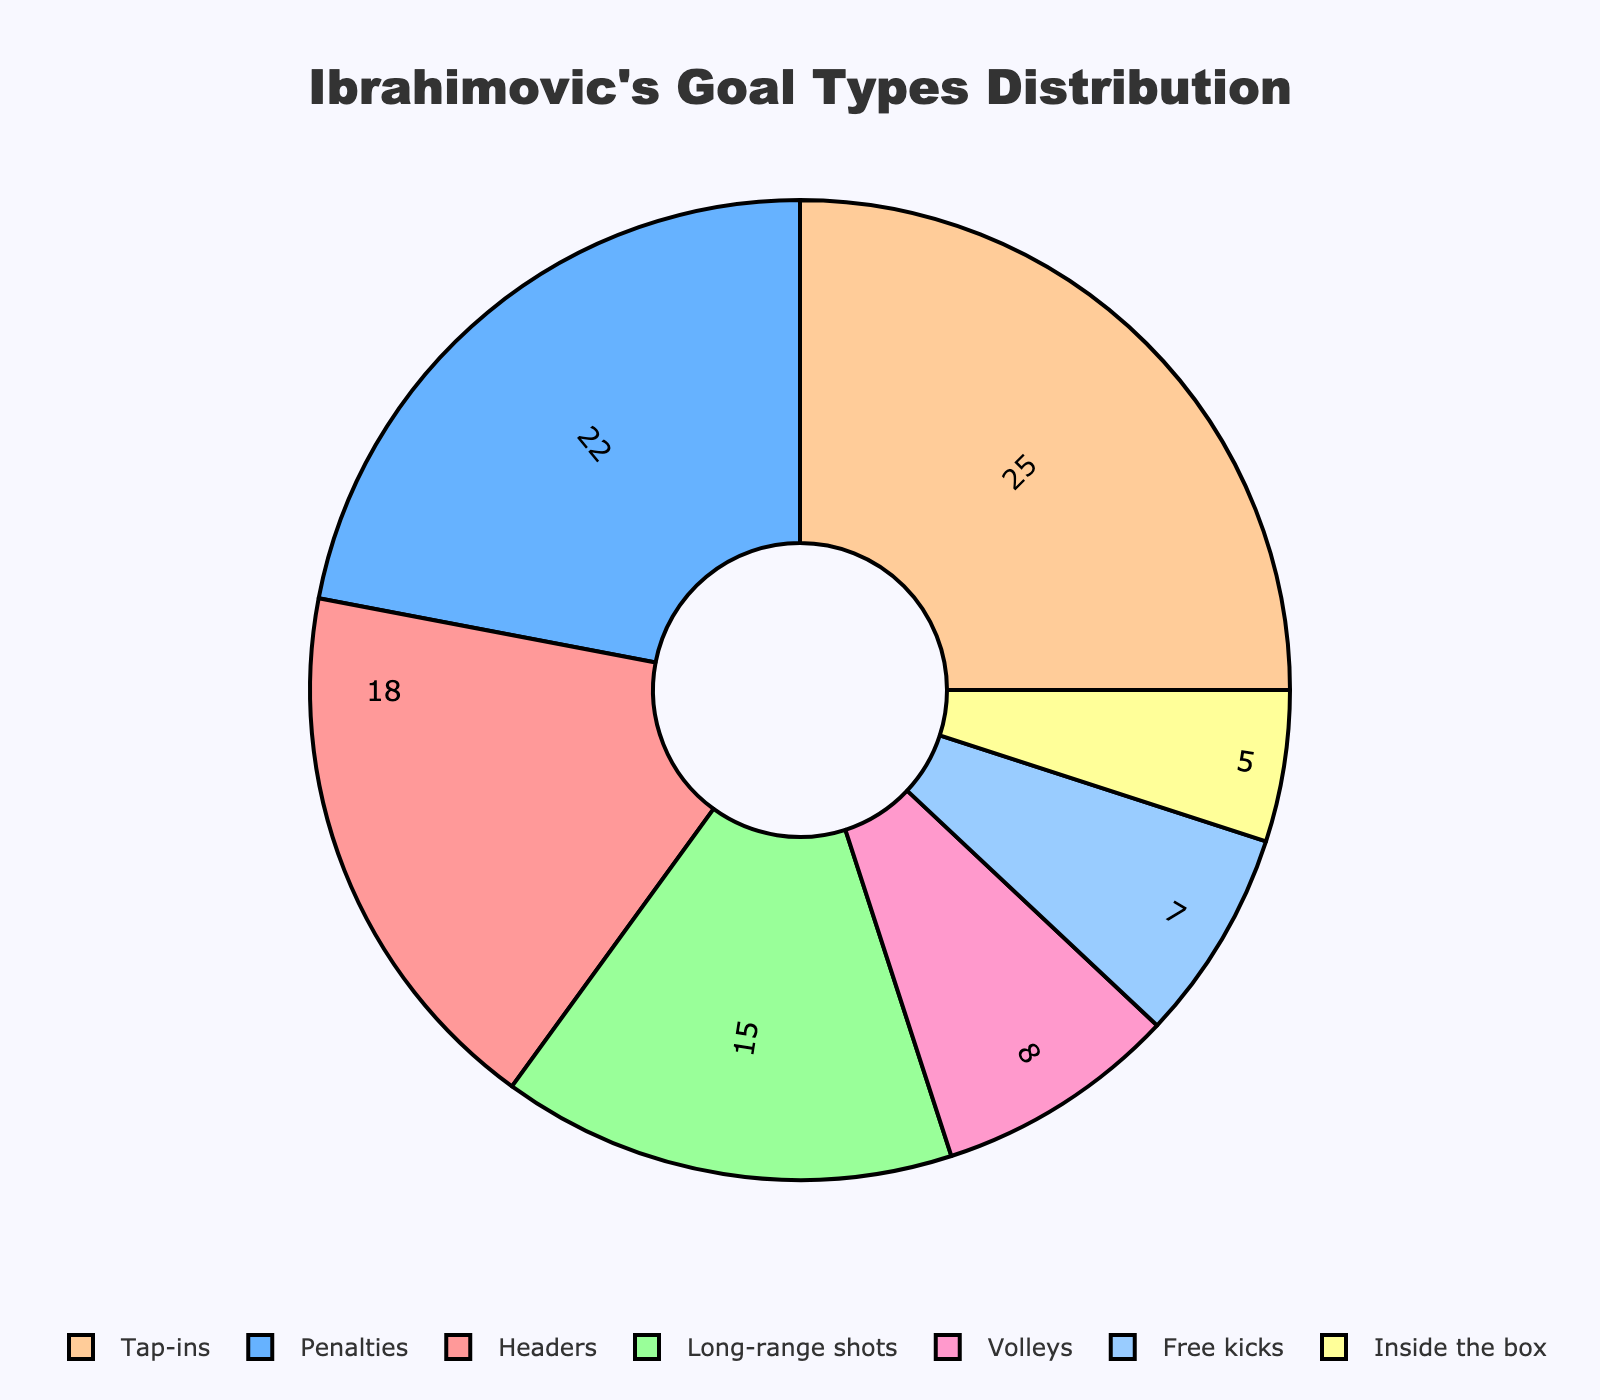what type of goal has the highest percentage? The pie chart shows different goal types and their respective percentage share. The goal type with the highest percentage will have the largest sector in the pie chart. The largest sector represents tap-ins.
Answer: Tap-ins How much more percentage of goals are scored by penalties compared to free kicks? First, find the percentage for penalties (22%) and for free kicks (7%) from the pie chart. Then, subtract the percentage of free kicks from penalties (22% - 7%).
Answer: 15% What is the combined percentage of goals for headers and long-range shots? Headers have a percentage of 18%, and long-range shots have 15%. Add these two percentages together (18% + 15%).
Answer: 33% Are there more goals scored by tap-ins or by headers and inside the box combined? Compare the percentage of tap-ins (25%) with the combined percentage of headers (18%) and inside the box (5%). The combined percentage is 18% + 5% = 23%, and tap-ins are 25%.
Answer: Tap-ins Which type of goals makes up less than 10% of the total goals? From the pie chart, identify the sectors with percentages less than 10%: Volleys (8%), Free kicks (7%), and Inside the box (5%).
Answer: Volleys, Free kicks, Inside the box How much more percentage of goals are tap-ins compared to long-range shots? First, find the percentage for tap-ins (25%) and long-range shots (15%) from the pie chart. Then subtract the percentage of long-range shots from tap-ins (25% - 15%).
Answer: 10% What is the total percentage of goals coming from penalties and headers combined? Find the percentage for penalties (22%) and headers (18%) from the pie chart. Then add these two percentages together (22% + 18%).
Answer: 40% What proportion of goals are either from volleys or free kicks? From the pie chart, identify the percentages for volleys (8%) and free kicks (7%). Add these two percentages together (8% + 7%).
Answer: 15% Is the goal type "inside the box" the least common, and if not, which is? Check the percentages for all the goal types. The goal type with the lowest percentage of goals is inside the box with 5%.
Answer: Inside the box How does the percentage of goals scored from headers compare to the percentage scored from other types of goals combined? Headers have a percentage of 18%, while all other goal types (penalties, long-range shots, tap-ins, volleys, free kicks, and inside the box) sum up to 82%. Compare the two: 18% (headers) vs. 82% (others).
Answer: Others 